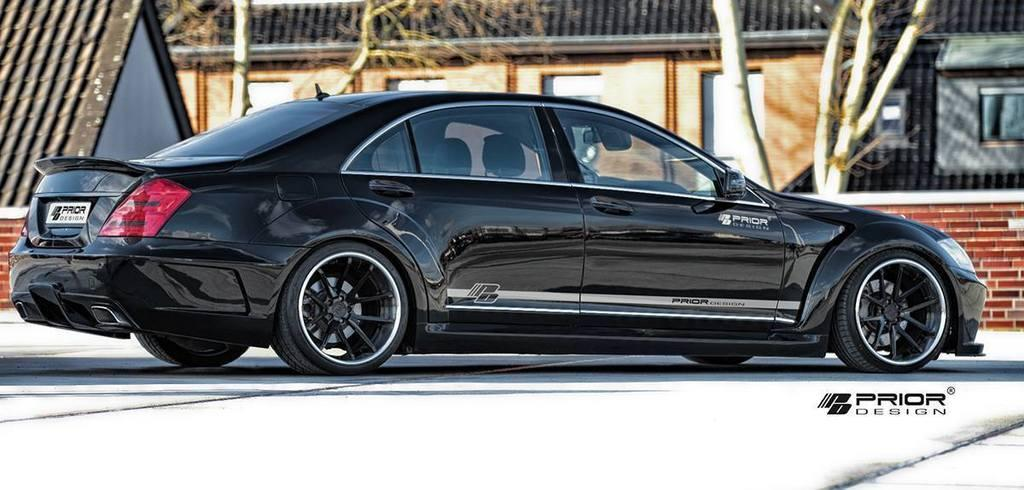What type of vehicle is in the image? There is a black car in the image. Where is the car located? The car is on a road. What can be seen in the background of the image? There is a house and trees in the background of the image. What features can be observed on the house? The house has windows. What type of celery is being used to fan the flame in the image? There is no celery or flame present in the image. What type of cloth is draped over the car in the image? There is no cloth draped over the car in the image. 